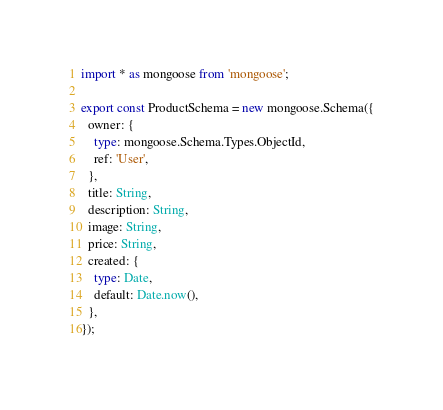Convert code to text. <code><loc_0><loc_0><loc_500><loc_500><_TypeScript_>import * as mongoose from 'mongoose';

export const ProductSchema = new mongoose.Schema({
  owner: {
    type: mongoose.Schema.Types.ObjectId,
    ref: 'User',
  },
  title: String,
  description: String,
  image: String,
  price: String,
  created: {
    type: Date,
    default: Date.now(),
  },
});
</code> 